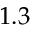<formula> <loc_0><loc_0><loc_500><loc_500>1 . 3</formula> 